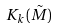Convert formula to latex. <formula><loc_0><loc_0><loc_500><loc_500>K _ { k } ( \tilde { M } )</formula> 